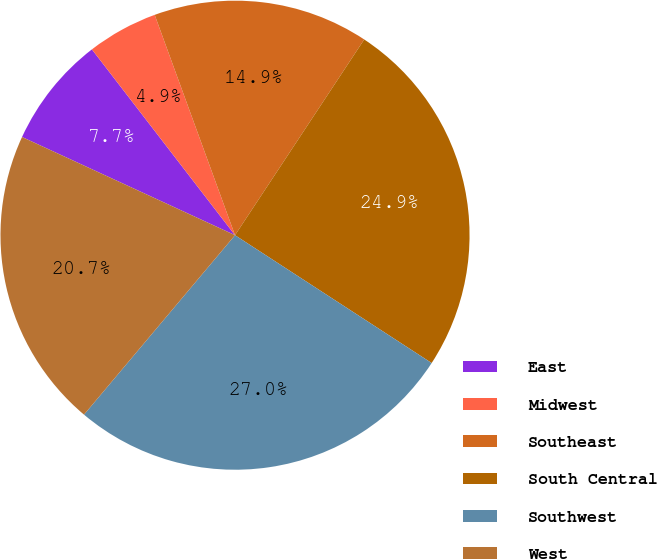Convert chart. <chart><loc_0><loc_0><loc_500><loc_500><pie_chart><fcel>East<fcel>Midwest<fcel>Southeast<fcel>South Central<fcel>Southwest<fcel>West<nl><fcel>7.68%<fcel>4.88%<fcel>14.85%<fcel>24.89%<fcel>26.96%<fcel>20.74%<nl></chart> 